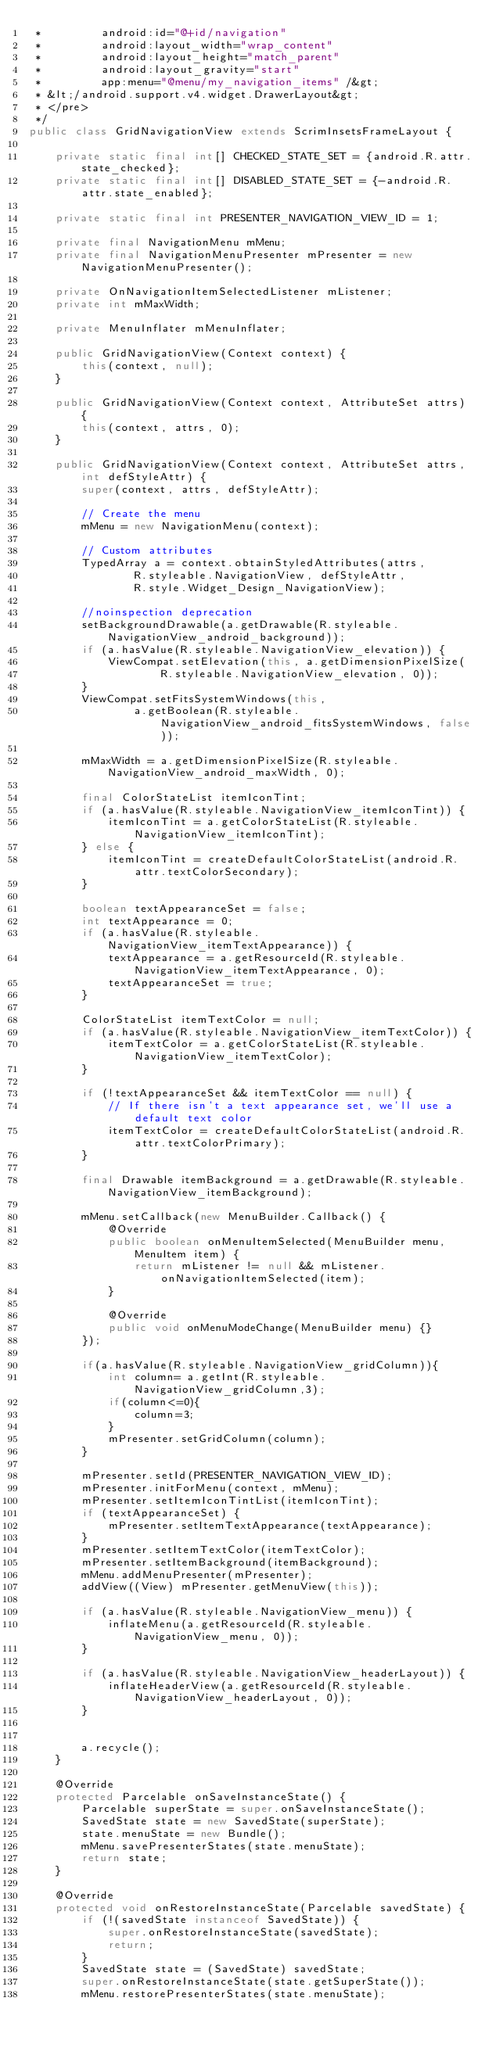Convert code to text. <code><loc_0><loc_0><loc_500><loc_500><_Java_> *         android:id="@+id/navigation"
 *         android:layout_width="wrap_content"
 *         android:layout_height="match_parent"
 *         android:layout_gravity="start"
 *         app:menu="@menu/my_navigation_items" /&gt;
 * &lt;/android.support.v4.widget.DrawerLayout&gt;
 * </pre>
 */
public class GridNavigationView extends ScrimInsetsFrameLayout {

    private static final int[] CHECKED_STATE_SET = {android.R.attr.state_checked};
    private static final int[] DISABLED_STATE_SET = {-android.R.attr.state_enabled};

    private static final int PRESENTER_NAVIGATION_VIEW_ID = 1;

    private final NavigationMenu mMenu;
    private final NavigationMenuPresenter mPresenter = new NavigationMenuPresenter();

    private OnNavigationItemSelectedListener mListener;
    private int mMaxWidth;

    private MenuInflater mMenuInflater;

    public GridNavigationView(Context context) {
        this(context, null);
    }

    public GridNavigationView(Context context, AttributeSet attrs) {
        this(context, attrs, 0);
    }

    public GridNavigationView(Context context, AttributeSet attrs, int defStyleAttr) {
        super(context, attrs, defStyleAttr);

        // Create the menu
        mMenu = new NavigationMenu(context);

        // Custom attributes
        TypedArray a = context.obtainStyledAttributes(attrs,
                R.styleable.NavigationView, defStyleAttr,
                R.style.Widget_Design_NavigationView);

        //noinspection deprecation
        setBackgroundDrawable(a.getDrawable(R.styleable.NavigationView_android_background));
        if (a.hasValue(R.styleable.NavigationView_elevation)) {
            ViewCompat.setElevation(this, a.getDimensionPixelSize(
                    R.styleable.NavigationView_elevation, 0));
        }
        ViewCompat.setFitsSystemWindows(this,
                a.getBoolean(R.styleable.NavigationView_android_fitsSystemWindows, false));

        mMaxWidth = a.getDimensionPixelSize(R.styleable.NavigationView_android_maxWidth, 0);

        final ColorStateList itemIconTint;
        if (a.hasValue(R.styleable.NavigationView_itemIconTint)) {
            itemIconTint = a.getColorStateList(R.styleable.NavigationView_itemIconTint);
        } else {
            itemIconTint = createDefaultColorStateList(android.R.attr.textColorSecondary);
        }

        boolean textAppearanceSet = false;
        int textAppearance = 0;
        if (a.hasValue(R.styleable.NavigationView_itemTextAppearance)) {
            textAppearance = a.getResourceId(R.styleable.NavigationView_itemTextAppearance, 0);
            textAppearanceSet = true;
        }

        ColorStateList itemTextColor = null;
        if (a.hasValue(R.styleable.NavigationView_itemTextColor)) {
            itemTextColor = a.getColorStateList(R.styleable.NavigationView_itemTextColor);
        }

        if (!textAppearanceSet && itemTextColor == null) {
            // If there isn't a text appearance set, we'll use a default text color
            itemTextColor = createDefaultColorStateList(android.R.attr.textColorPrimary);
        }

        final Drawable itemBackground = a.getDrawable(R.styleable.NavigationView_itemBackground);

        mMenu.setCallback(new MenuBuilder.Callback() {
            @Override
            public boolean onMenuItemSelected(MenuBuilder menu, MenuItem item) {
                return mListener != null && mListener.onNavigationItemSelected(item);
            }

            @Override
            public void onMenuModeChange(MenuBuilder menu) {}
        });

        if(a.hasValue(R.styleable.NavigationView_gridColumn)){
            int column= a.getInt(R.styleable.NavigationView_gridColumn,3);
            if(column<=0){
                column=3;
            }
            mPresenter.setGridColumn(column);
        }

        mPresenter.setId(PRESENTER_NAVIGATION_VIEW_ID);
        mPresenter.initForMenu(context, mMenu);
        mPresenter.setItemIconTintList(itemIconTint);
        if (textAppearanceSet) {
            mPresenter.setItemTextAppearance(textAppearance);
        }
        mPresenter.setItemTextColor(itemTextColor);
        mPresenter.setItemBackground(itemBackground);
        mMenu.addMenuPresenter(mPresenter);
        addView((View) mPresenter.getMenuView(this));

        if (a.hasValue(R.styleable.NavigationView_menu)) {
            inflateMenu(a.getResourceId(R.styleable.NavigationView_menu, 0));
        }

        if (a.hasValue(R.styleable.NavigationView_headerLayout)) {
            inflateHeaderView(a.getResourceId(R.styleable.NavigationView_headerLayout, 0));
        }


        a.recycle();
    }

    @Override
    protected Parcelable onSaveInstanceState() {
        Parcelable superState = super.onSaveInstanceState();
        SavedState state = new SavedState(superState);
        state.menuState = new Bundle();
        mMenu.savePresenterStates(state.menuState);
        return state;
    }

    @Override
    protected void onRestoreInstanceState(Parcelable savedState) {
        if (!(savedState instanceof SavedState)) {
            super.onRestoreInstanceState(savedState);
            return;
        }
        SavedState state = (SavedState) savedState;
        super.onRestoreInstanceState(state.getSuperState());
        mMenu.restorePresenterStates(state.menuState);</code> 